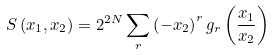Convert formula to latex. <formula><loc_0><loc_0><loc_500><loc_500>S \left ( x _ { 1 } , x _ { 2 } \right ) = 2 ^ { 2 N } \sum _ { r } \left ( - x _ { 2 } \right ) ^ { r } g _ { r } \left ( \frac { x _ { 1 } } { x _ { 2 } } \right )</formula> 